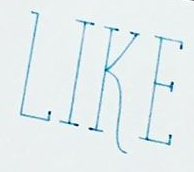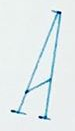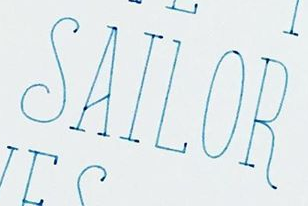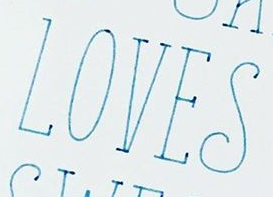Transcribe the words shown in these images in order, separated by a semicolon. LIKE; A; SAILOR; LOVES 